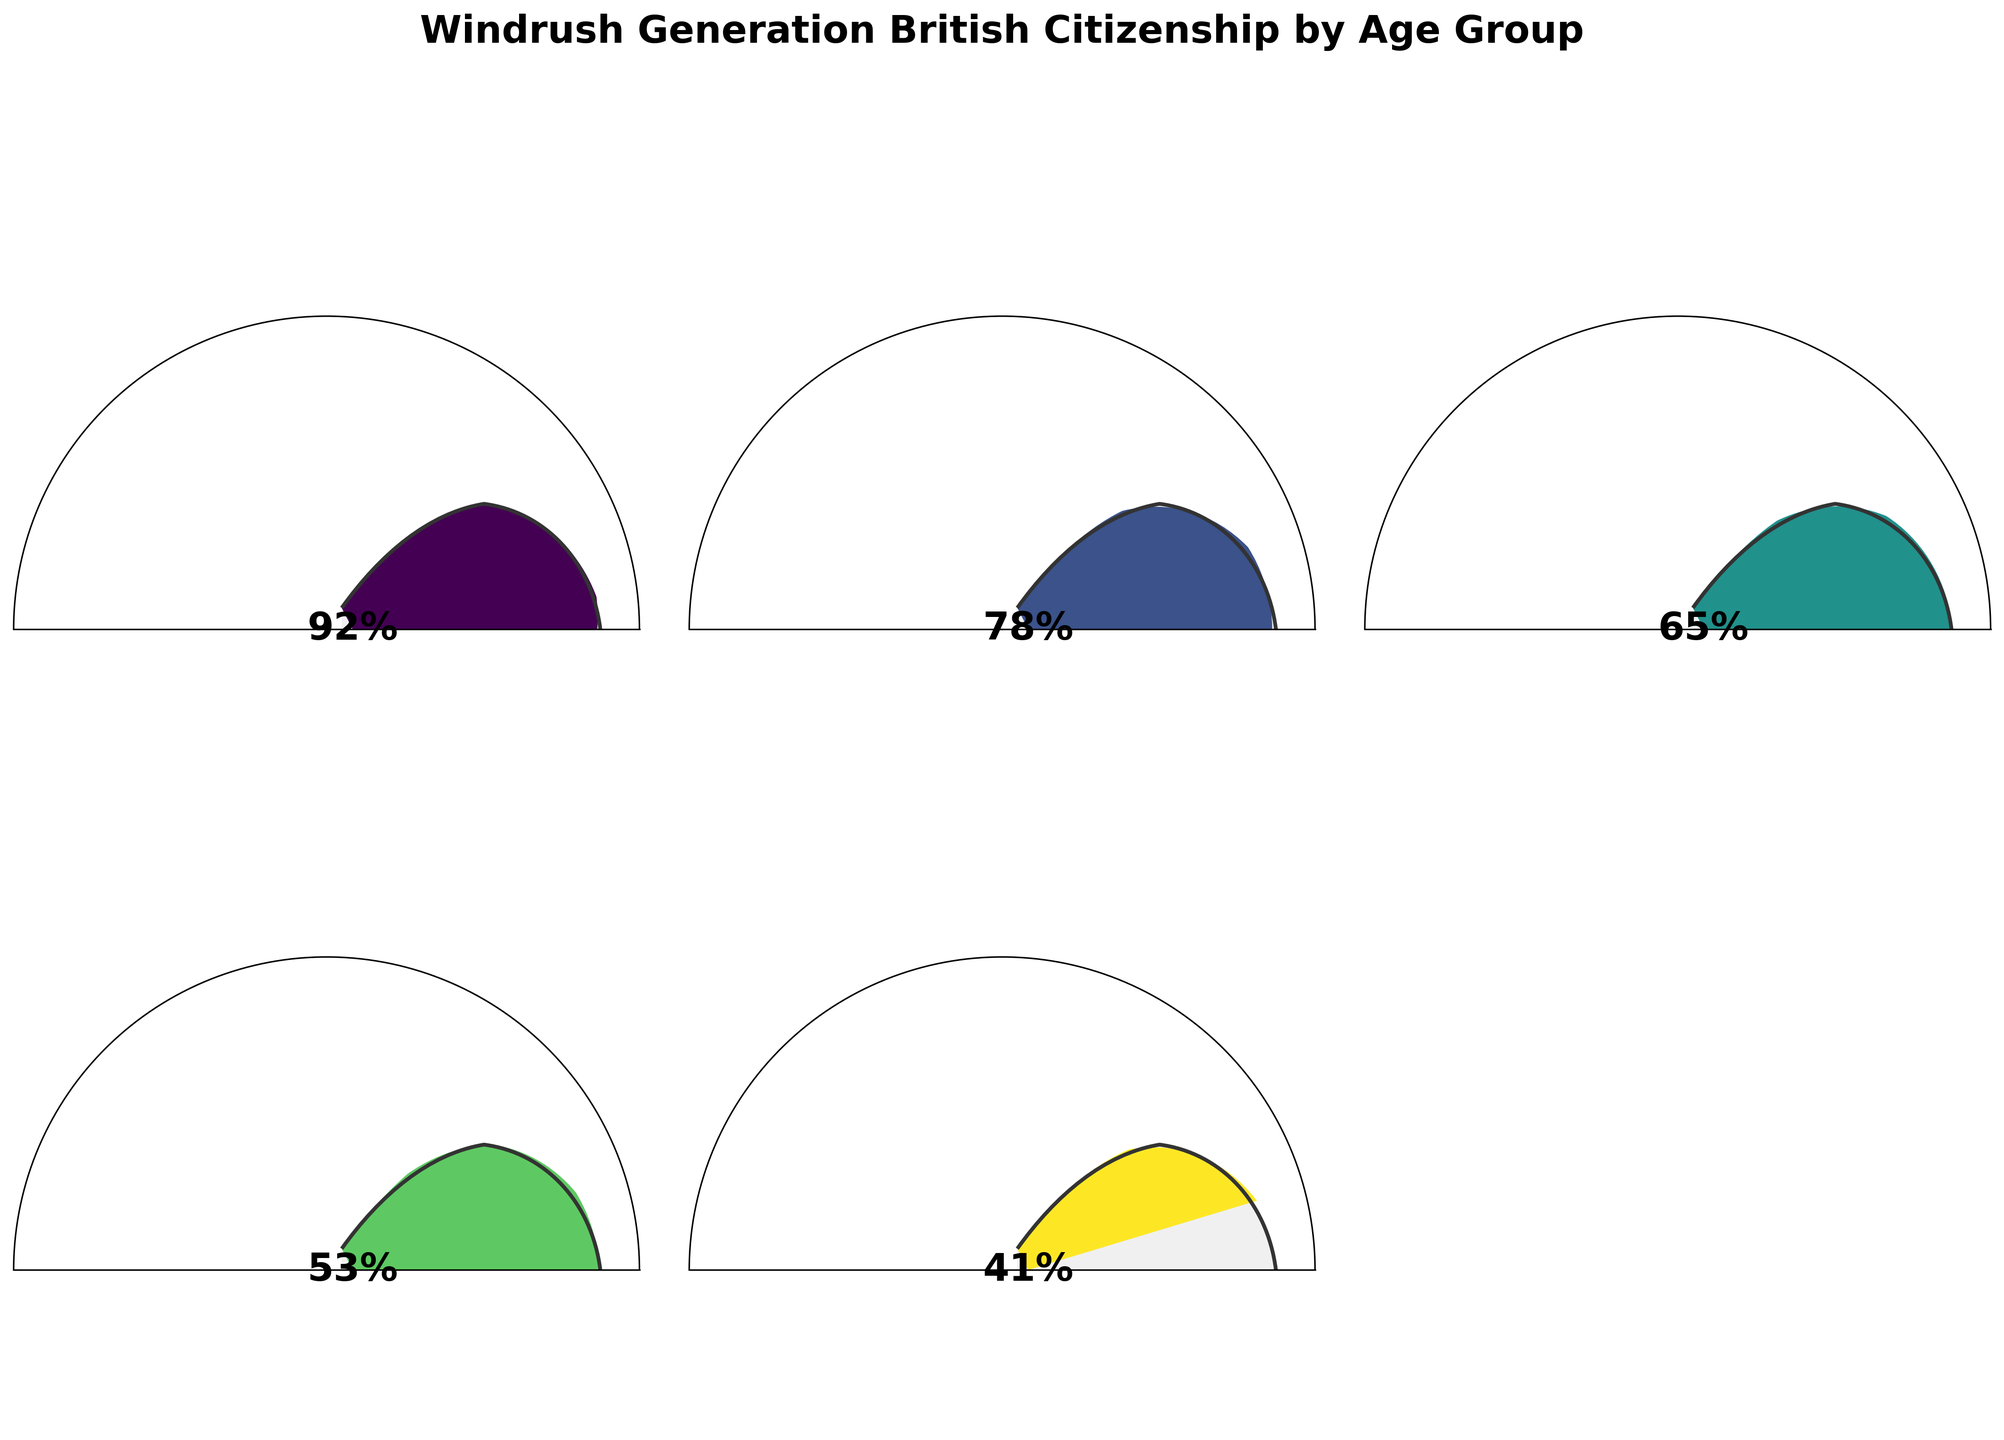What percentage of the Windrush Generation members aged 18-30 have secured their British citizenship? The gauge chart clearly shows a value of 92% for the age group 18-30.
Answer: 92% What is the average percentage of British citizenship across all age groups? Sum the percentages (92 + 78 + 65 + 53 + 41) and divide by the number of age groups (5), (92 + 78 + 65 + 53 + 41)/5 = 65.8%
Answer: 65.8% Which age group has the lowest percentage of members securing British citizenship? By comparing the percentages for each age group visually, the Over 75 group has the lowest value with 41%.
Answer: Over 75 How much more likely is a member of the 18-30 age group to have British citizenship compared to the 61-75 age group? Subtract the percentage of the 61-75 age group from that of the 18-30 age group: 92% - 53% = 39%.
Answer: 39% What is the total percentage covered by the age groups 31-45 and 46-60 combined? Add the percentages of the 31-45 and 46-60 age groups: 78% + 65% = 143%.
Answer: 143% Among the given age groups, how many show a percentage of British citizenship above 50%? Identify age groups with percentages above 50%: 18-30, 31-45, 46-60, 61-75. Therefore, 4 age groups.
Answer: 4 What's the difference in citizenship percentage between the youngest age group (18-30) and the oldest age group (Over 75)? Subtract the percentage of the Over 75 age group from the 18-30 age group: 92% - 41% = 51%.
Answer: 51% What is the median percentage of British citizenship across the age groups? List the percentages in ascending order (41, 53, 65, 78, 92) and find the middle value. The median percentage is 65%.
Answer: 65% Which age group has the second highest percentage of British citizenship? By comparing the listed percentages visually, the 31-45 age group has the second highest value of 78% (after 18-30 with 92%).
Answer: 31-45 How many of the age groups have a British citizenship percentage below 70%? Identify age groups with percentages below 70%: 46-60, 61-75, Over 75. Therefore, 3 age groups.
Answer: 3 